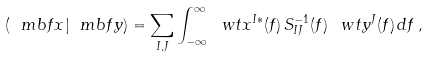Convert formula to latex. <formula><loc_0><loc_0><loc_500><loc_500>( \ m b f { x } | \ m b f { y } ) = \sum _ { I , J } \int _ { - \infty } ^ { \infty } \ w t { x } ^ { I * } ( f ) \, S ^ { - 1 } _ { I J } ( f ) \, \ w t { y } ^ { J } ( f ) \, d f \, ,</formula> 